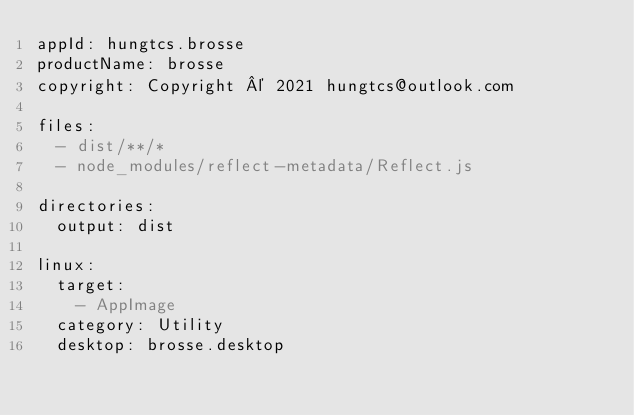<code> <loc_0><loc_0><loc_500><loc_500><_YAML_>appId: hungtcs.brosse
productName: brosse
copyright: Copyright © 2021 hungtcs@outlook.com

files:
  - dist/**/*
  - node_modules/reflect-metadata/Reflect.js

directories:
  output: dist

linux:
  target:
    - AppImage
  category: Utility
  desktop: brosse.desktop
</code> 